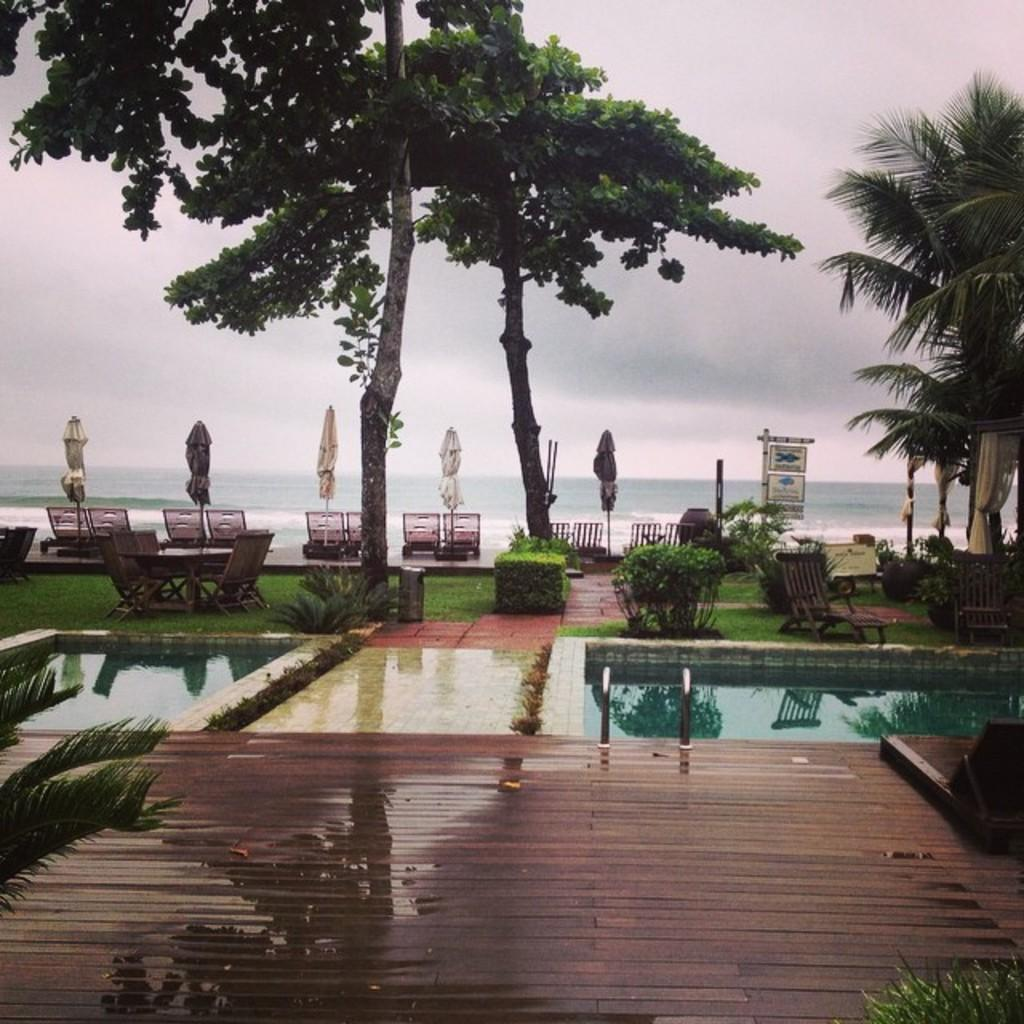What is the primary element visible in the image? There is water in the image. What type of natural vegetation can be seen in the image? There are trees in the image. What objects are present in the background of the image? In the background, there are chairs, sign boards, umbrellas, and clouds. What flavor of dog food is being advertised on the sign boards in the image? There are no dogs or dog food mentioned or depicted in the image, and the sign boards do not advertise any specific flavors. 